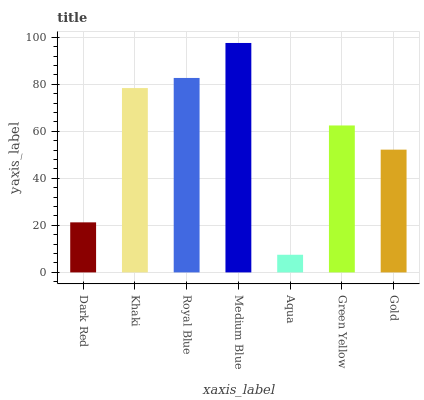Is Aqua the minimum?
Answer yes or no. Yes. Is Medium Blue the maximum?
Answer yes or no. Yes. Is Khaki the minimum?
Answer yes or no. No. Is Khaki the maximum?
Answer yes or no. No. Is Khaki greater than Dark Red?
Answer yes or no. Yes. Is Dark Red less than Khaki?
Answer yes or no. Yes. Is Dark Red greater than Khaki?
Answer yes or no. No. Is Khaki less than Dark Red?
Answer yes or no. No. Is Green Yellow the high median?
Answer yes or no. Yes. Is Green Yellow the low median?
Answer yes or no. Yes. Is Dark Red the high median?
Answer yes or no. No. Is Khaki the low median?
Answer yes or no. No. 